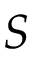<formula> <loc_0><loc_0><loc_500><loc_500>S</formula> 